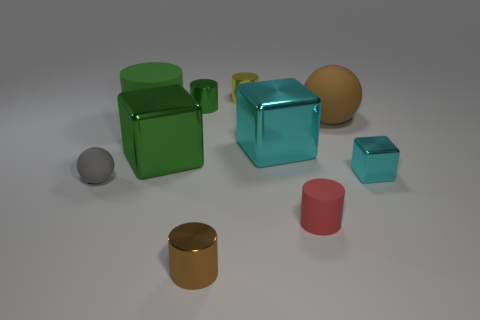Subtract all red cylinders. How many cylinders are left? 4 Subtract all large green matte cylinders. How many cylinders are left? 4 Subtract all gray cylinders. Subtract all blue cubes. How many cylinders are left? 5 Subtract all cubes. How many objects are left? 7 Subtract all green cylinders. Subtract all cubes. How many objects are left? 5 Add 7 small brown shiny things. How many small brown shiny things are left? 8 Add 2 tiny green metallic cylinders. How many tiny green metallic cylinders exist? 3 Subtract 0 green balls. How many objects are left? 10 